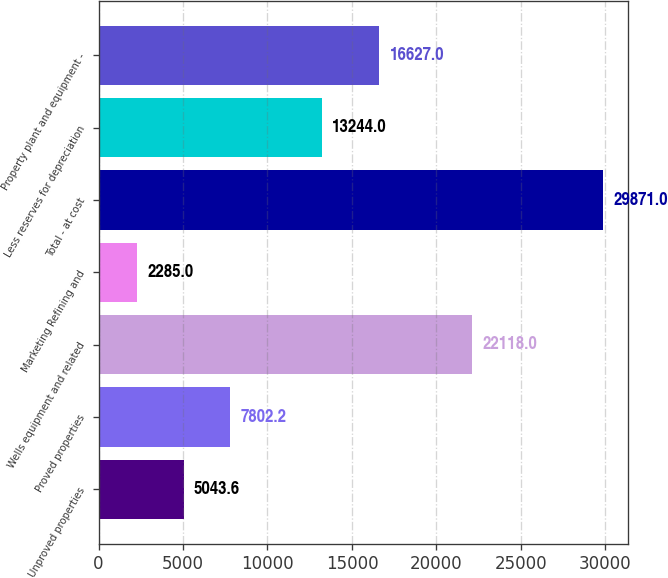Convert chart to OTSL. <chart><loc_0><loc_0><loc_500><loc_500><bar_chart><fcel>Unproved properties<fcel>Proved properties<fcel>Wells equipment and related<fcel>Marketing Refining and<fcel>Total - at cost<fcel>Less reserves for depreciation<fcel>Property plant and equipment -<nl><fcel>5043.6<fcel>7802.2<fcel>22118<fcel>2285<fcel>29871<fcel>13244<fcel>16627<nl></chart> 